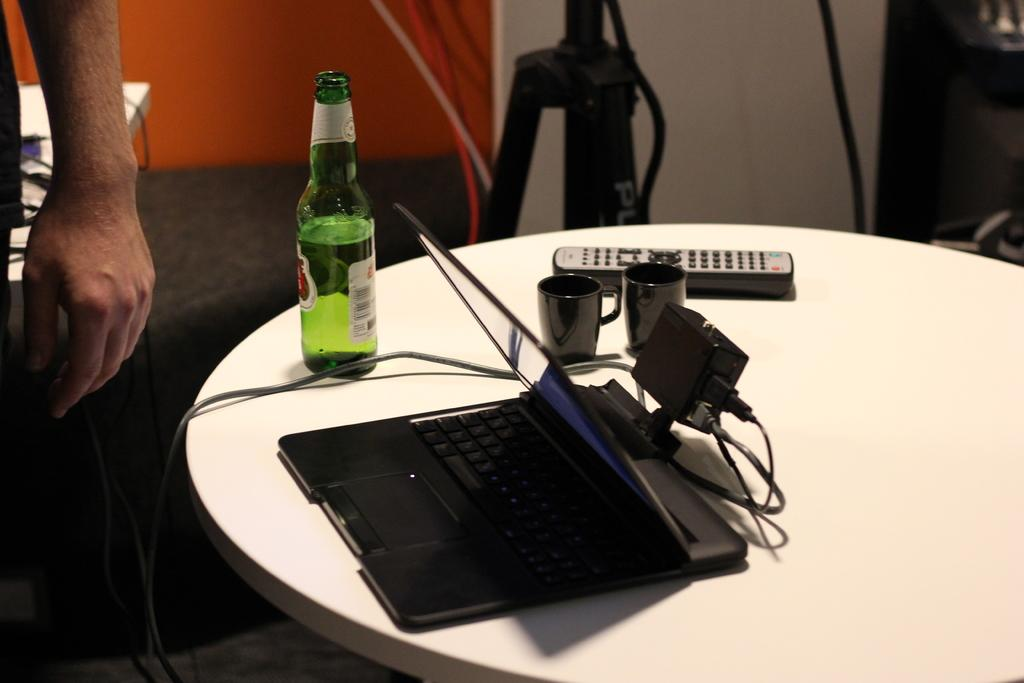What is the main object in the center of the image? There is a table in the center of the image. What items can be found on the table? On the table, there is a beer bottle, a tab, a charger, a remote, and glasses. Can you describe the human presence in the image? There is a human hand on the left top of the image. What can be seen in the background of the image? There is a wall visible in the background, along with a few objects. How many cards are being used by the person in the image? There are no cards visible in the image. Can you see any feathers in the image? There are no feathers present in the image. 